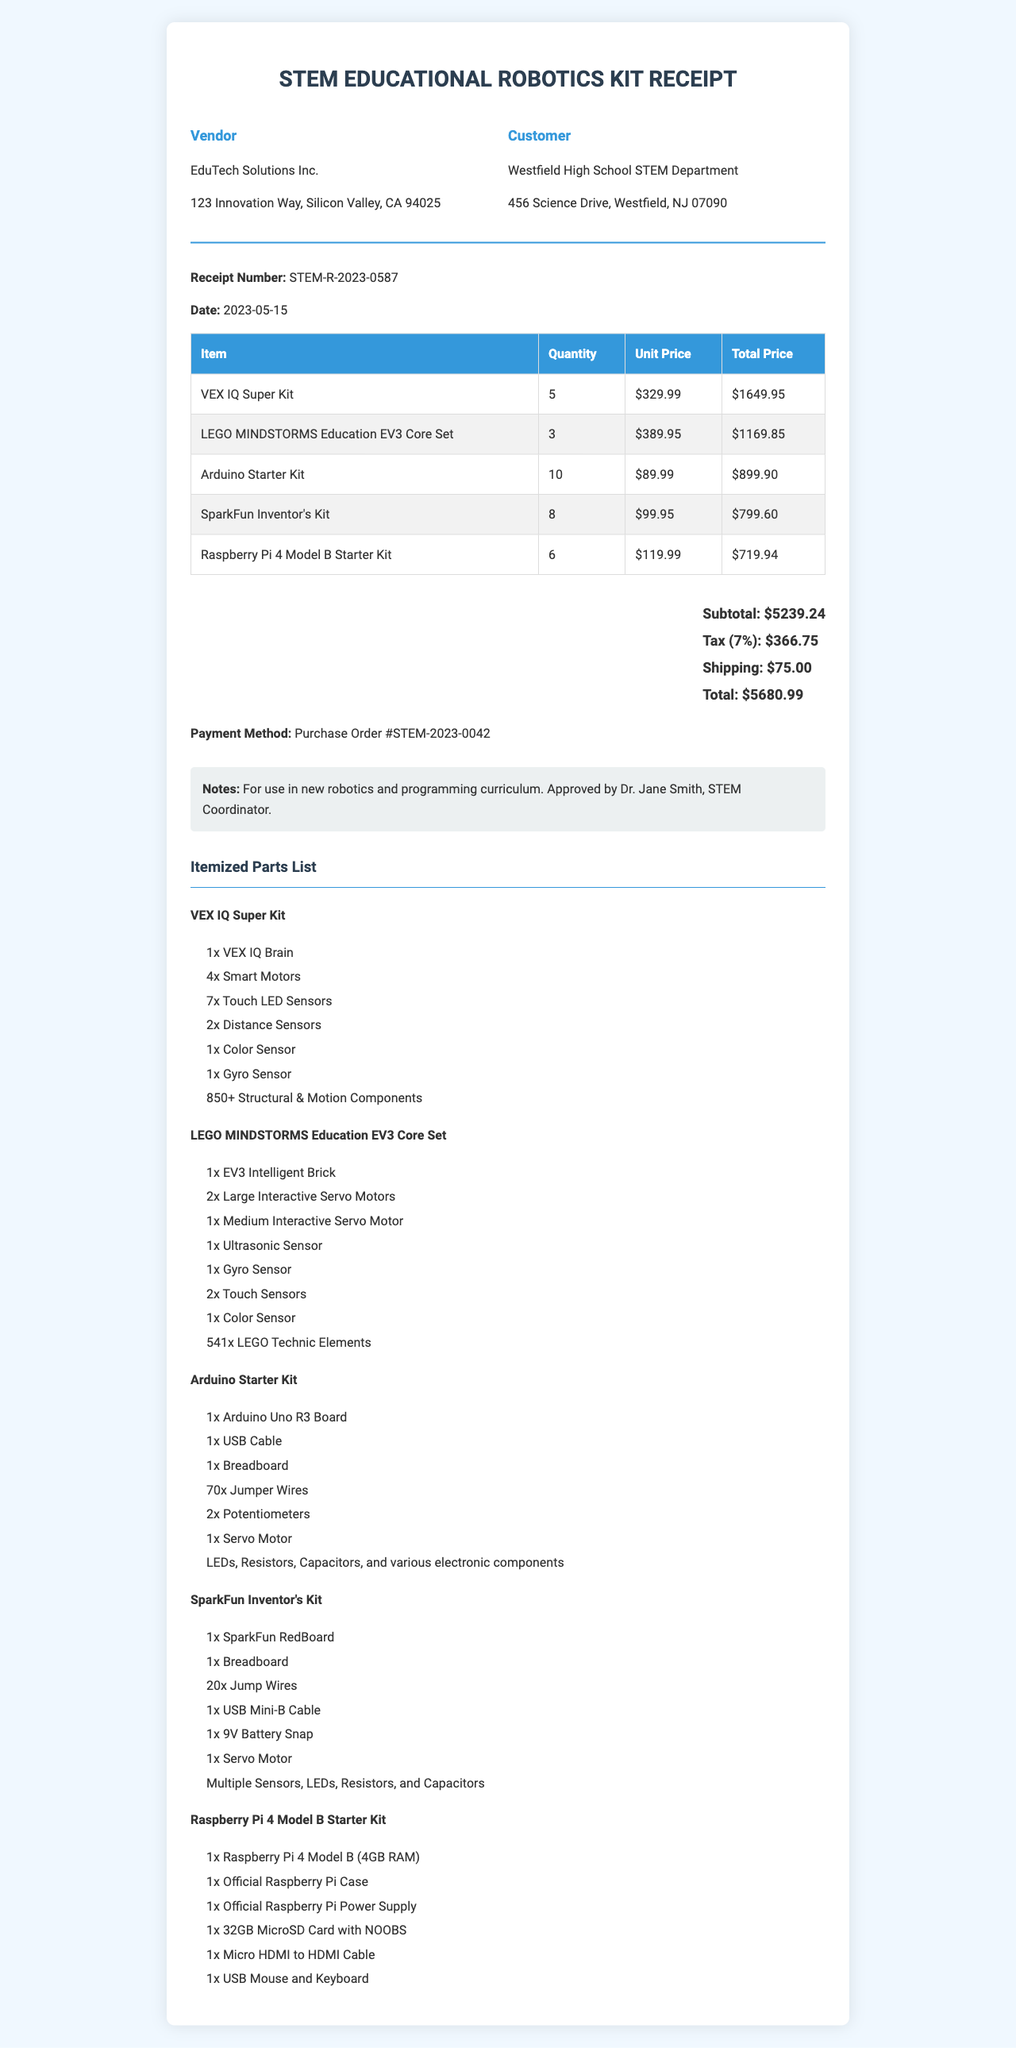What is the receipt number? The receipt number is a unique identifier for this transaction, found at the top of the document.
Answer: STEM-R-2023-0587 What is the total amount charged? The total amount is the final cost that includes all items, taxes, and shipping, located in the total section of the document.
Answer: $5680.99 Who is the vendor? The vendor is the company from which the items were purchased, stated in the header section.
Answer: EduTech Solutions Inc How many Arduino Starter Kits were purchased? The quantity of a specific item can be found in the itemized list of purchased items.
Answer: 10 What is the tax rate applied? The tax rate is a percentage of the subtotal that is charged as tax, indicated in the financial summary.
Answer: 7% What is the purpose of this purchase? The purpose is mentioned in the notes section, which gives additional context regarding the purchase.
Answer: For use in new robotics and programming curriculum How many total items were purchased? The total number of purchased items can be calculated by reviewing the quantity column in the itemized list and summing those values.
Answer: 42 Which payment method was used? The payment method is specified in the financial summary of the document.
Answer: Purchase Order #STEM-2023-0042 What item contains the most parts? This question requires reasoning about the itemized parts lists, specifically comparing the number of parts in each kit.
Answer: VEX IQ Super Kit 